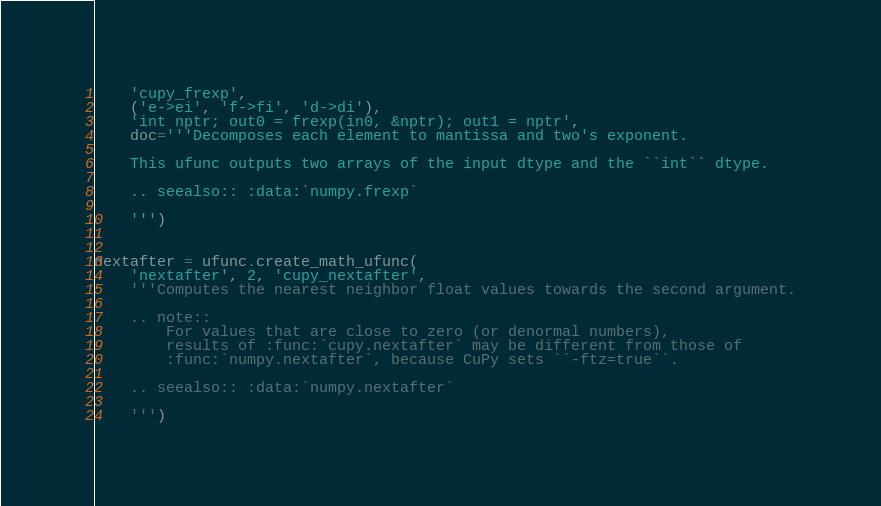<code> <loc_0><loc_0><loc_500><loc_500><_Python_>    'cupy_frexp',
    ('e->ei', 'f->fi', 'd->di'),
    'int nptr; out0 = frexp(in0, &nptr); out1 = nptr',
    doc='''Decomposes each element to mantissa and two's exponent.

    This ufunc outputs two arrays of the input dtype and the ``int`` dtype.

    .. seealso:: :data:`numpy.frexp`

    ''')


nextafter = ufunc.create_math_ufunc(
    'nextafter', 2, 'cupy_nextafter',
    '''Computes the nearest neighbor float values towards the second argument.

    .. note::
        For values that are close to zero (or denormal numbers),
        results of :func:`cupy.nextafter` may be different from those of
        :func:`numpy.nextafter`, because CuPy sets ``-ftz=true``.

    .. seealso:: :data:`numpy.nextafter`

    ''')
</code> 